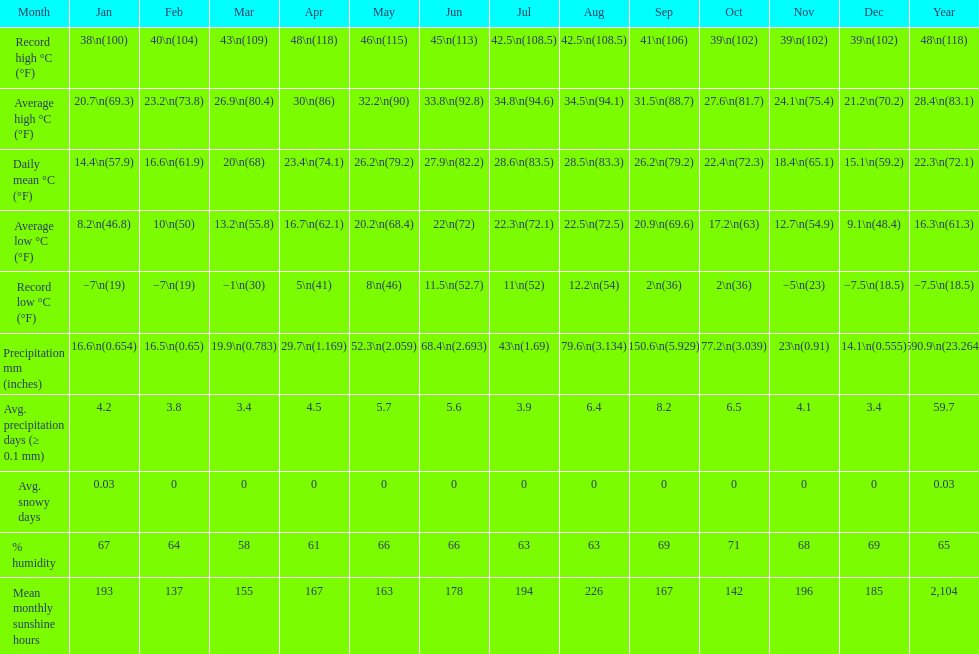Are there more snowy days in december or january? January. 